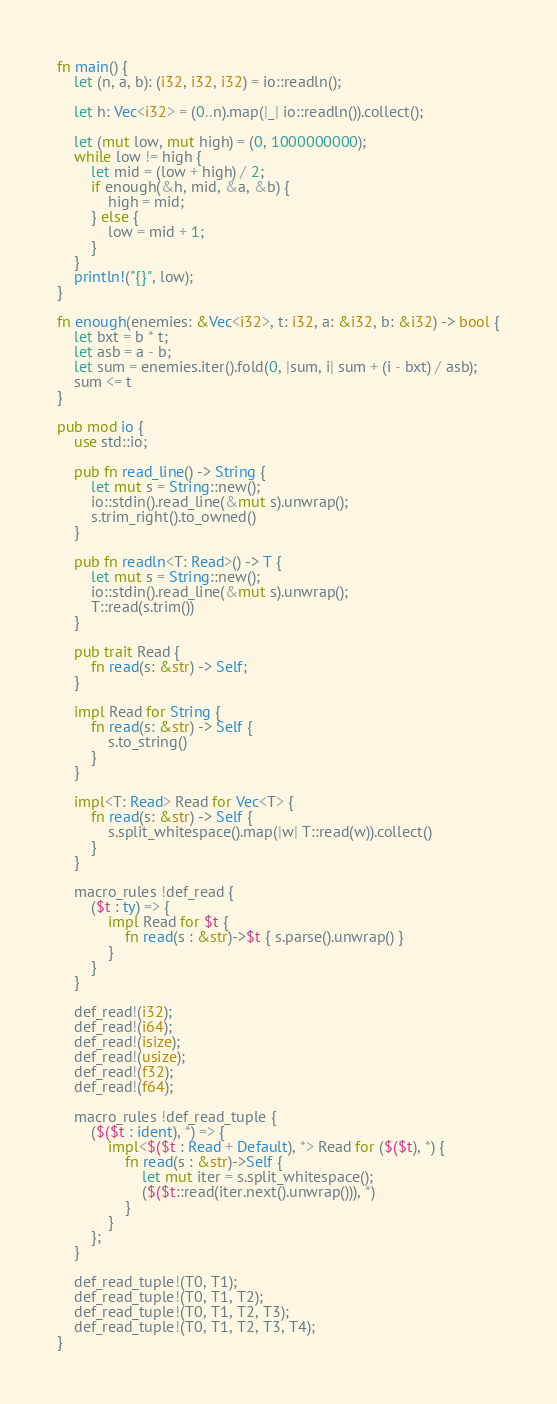<code> <loc_0><loc_0><loc_500><loc_500><_Rust_>fn main() {
    let (n, a, b): (i32, i32, i32) = io::readln();

    let h: Vec<i32> = (0..n).map(|_| io::readln()).collect();

    let (mut low, mut high) = (0, 1000000000);
    while low != high {
        let mid = (low + high) / 2;
        if enough(&h, mid, &a, &b) {
            high = mid;
        } else {
            low = mid + 1;
        }
    }
    println!("{}", low);
}

fn enough(enemies: &Vec<i32>, t: i32, a: &i32, b: &i32) -> bool {
    let bxt = b * t;
    let asb = a - b;
    let sum = enemies.iter().fold(0, |sum, i| sum + (i - bxt) / asb);
    sum <= t
}

pub mod io {
    use std::io;

    pub fn read_line() -> String {
        let mut s = String::new();
        io::stdin().read_line(&mut s).unwrap();
        s.trim_right().to_owned()
    }

    pub fn readln<T: Read>() -> T {
        let mut s = String::new();
        io::stdin().read_line(&mut s).unwrap();
        T::read(s.trim())
    }

    pub trait Read {
        fn read(s: &str) -> Self;
    }

    impl Read for String {
        fn read(s: &str) -> Self {
            s.to_string()
        }
    }

    impl<T: Read> Read for Vec<T> {
        fn read(s: &str) -> Self {
            s.split_whitespace().map(|w| T::read(w)).collect()
        }
    }

    macro_rules !def_read {
        ($t : ty) => {
            impl Read for $t {
                fn read(s : &str)->$t { s.parse().unwrap() }
            }
        }
    }

    def_read!(i32);
    def_read!(i64);
    def_read!(isize);
    def_read!(usize);
    def_read!(f32);
    def_read!(f64);

    macro_rules !def_read_tuple {
        ($($t : ident), *) => {
            impl<$($t : Read + Default), *> Read for ($($t), *) {
                fn read(s : &str)->Self {
                    let mut iter = s.split_whitespace();
                    ($($t::read(iter.next().unwrap())), *)
                }
            }
        };
    }

    def_read_tuple!(T0, T1);
    def_read_tuple!(T0, T1, T2);
    def_read_tuple!(T0, T1, T2, T3);
    def_read_tuple!(T0, T1, T2, T3, T4);
}</code> 